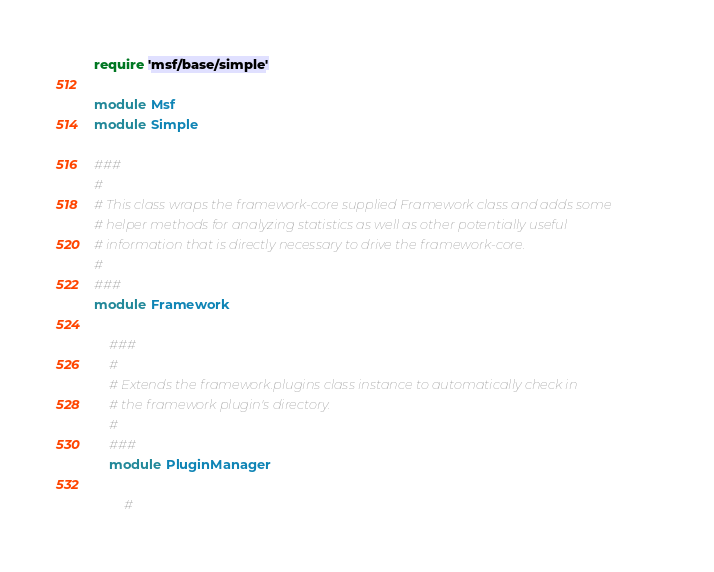Convert code to text. <code><loc_0><loc_0><loc_500><loc_500><_Ruby_>require 'msf/base/simple'

module Msf
module Simple

###
#
# This class wraps the framework-core supplied Framework class and adds some
# helper methods for analyzing statistics as well as other potentially useful
# information that is directly necessary to drive the framework-core.
#
###
module Framework

	###
	#
	# Extends the framework.plugins class instance to automatically check in
	# the framework plugin's directory.
	#
	###
	module PluginManager

		#</code> 